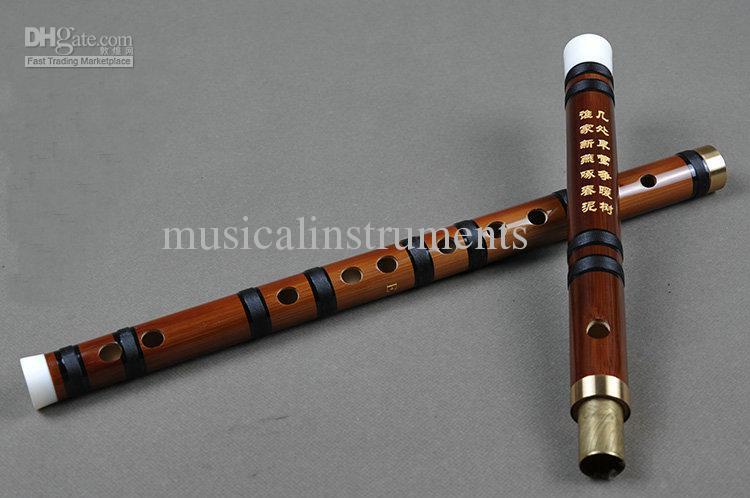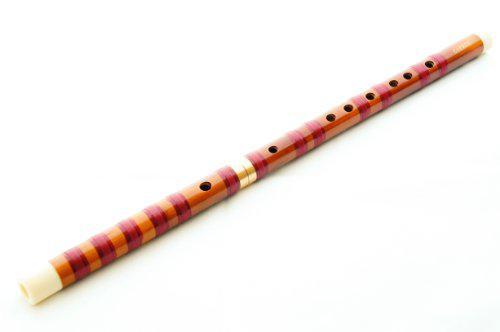The first image is the image on the left, the second image is the image on the right. Evaluate the accuracy of this statement regarding the images: "In at least one image there is a brown wooden flute with only 7 drilled holes in it.". Is it true? Answer yes or no. No. The first image is the image on the left, the second image is the image on the right. Given the left and right images, does the statement "Each image contains only one flute, which is displayed somewhat horizontally." hold true? Answer yes or no. No. 